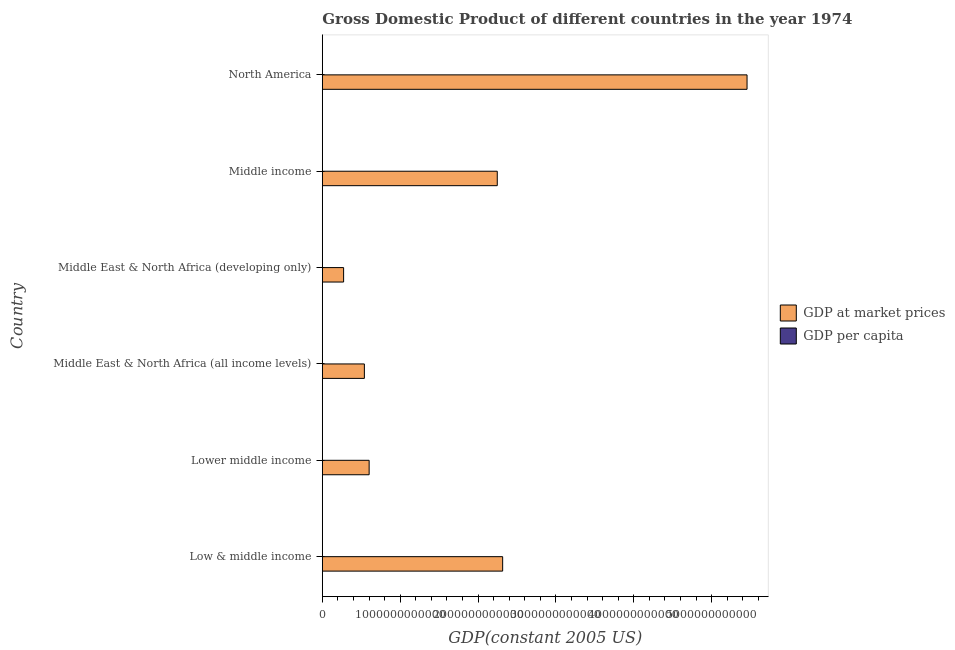How many different coloured bars are there?
Give a very brief answer. 2. Are the number of bars per tick equal to the number of legend labels?
Keep it short and to the point. Yes. Are the number of bars on each tick of the Y-axis equal?
Your response must be concise. Yes. How many bars are there on the 3rd tick from the top?
Provide a short and direct response. 2. In how many cases, is the number of bars for a given country not equal to the number of legend labels?
Make the answer very short. 0. What is the gdp at market prices in Middle East & North Africa (all income levels)?
Provide a short and direct response. 5.40e+11. Across all countries, what is the maximum gdp per capita?
Offer a terse response. 2.30e+04. Across all countries, what is the minimum gdp at market prices?
Offer a very short reply. 2.73e+11. In which country was the gdp at market prices minimum?
Your answer should be very brief. Middle East & North Africa (developing only). What is the total gdp per capita in the graph?
Provide a succinct answer. 3.06e+04. What is the difference between the gdp per capita in Middle income and that in North America?
Keep it short and to the point. -2.22e+04. What is the difference between the gdp per capita in Middle East & North Africa (all income levels) and the gdp at market prices in Middle East & North Africa (developing only)?
Your answer should be compact. -2.73e+11. What is the average gdp at market prices per country?
Ensure brevity in your answer.  1.91e+12. What is the difference between the gdp per capita and gdp at market prices in Low & middle income?
Provide a short and direct response. -2.32e+12. What is the ratio of the gdp per capita in Middle income to that in North America?
Provide a short and direct response. 0.04. What is the difference between the highest and the second highest gdp at market prices?
Your response must be concise. 3.14e+12. What is the difference between the highest and the lowest gdp per capita?
Ensure brevity in your answer.  2.26e+04. In how many countries, is the gdp per capita greater than the average gdp per capita taken over all countries?
Your response must be concise. 1. What does the 1st bar from the top in Low & middle income represents?
Provide a short and direct response. GDP per capita. What does the 2nd bar from the bottom in Low & middle income represents?
Ensure brevity in your answer.  GDP per capita. How many countries are there in the graph?
Give a very brief answer. 6. What is the difference between two consecutive major ticks on the X-axis?
Your answer should be compact. 1.00e+12. Are the values on the major ticks of X-axis written in scientific E-notation?
Your response must be concise. No. Does the graph contain grids?
Keep it short and to the point. No. How many legend labels are there?
Make the answer very short. 2. How are the legend labels stacked?
Your answer should be compact. Vertical. What is the title of the graph?
Your response must be concise. Gross Domestic Product of different countries in the year 1974. What is the label or title of the X-axis?
Your answer should be compact. GDP(constant 2005 US). What is the GDP(constant 2005 US) in GDP at market prices in Low & middle income?
Provide a succinct answer. 2.32e+12. What is the GDP(constant 2005 US) of GDP per capita in Low & middle income?
Make the answer very short. 789.55. What is the GDP(constant 2005 US) of GDP at market prices in Lower middle income?
Provide a short and direct response. 6.01e+11. What is the GDP(constant 2005 US) of GDP per capita in Lower middle income?
Your answer should be very brief. 461.53. What is the GDP(constant 2005 US) in GDP at market prices in Middle East & North Africa (all income levels)?
Offer a terse response. 5.40e+11. What is the GDP(constant 2005 US) in GDP per capita in Middle East & North Africa (all income levels)?
Offer a terse response. 3495.84. What is the GDP(constant 2005 US) of GDP at market prices in Middle East & North Africa (developing only)?
Offer a very short reply. 2.73e+11. What is the GDP(constant 2005 US) in GDP per capita in Middle East & North Africa (developing only)?
Your response must be concise. 1937.94. What is the GDP(constant 2005 US) of GDP at market prices in Middle income?
Give a very brief answer. 2.25e+12. What is the GDP(constant 2005 US) in GDP per capita in Middle income?
Your response must be concise. 827.87. What is the GDP(constant 2005 US) of GDP at market prices in North America?
Your response must be concise. 5.45e+12. What is the GDP(constant 2005 US) of GDP per capita in North America?
Keep it short and to the point. 2.30e+04. Across all countries, what is the maximum GDP(constant 2005 US) in GDP at market prices?
Offer a terse response. 5.45e+12. Across all countries, what is the maximum GDP(constant 2005 US) of GDP per capita?
Give a very brief answer. 2.30e+04. Across all countries, what is the minimum GDP(constant 2005 US) in GDP at market prices?
Give a very brief answer. 2.73e+11. Across all countries, what is the minimum GDP(constant 2005 US) of GDP per capita?
Keep it short and to the point. 461.53. What is the total GDP(constant 2005 US) of GDP at market prices in the graph?
Your answer should be very brief. 1.14e+13. What is the total GDP(constant 2005 US) in GDP per capita in the graph?
Give a very brief answer. 3.06e+04. What is the difference between the GDP(constant 2005 US) in GDP at market prices in Low & middle income and that in Lower middle income?
Keep it short and to the point. 1.71e+12. What is the difference between the GDP(constant 2005 US) of GDP per capita in Low & middle income and that in Lower middle income?
Your answer should be compact. 328.03. What is the difference between the GDP(constant 2005 US) in GDP at market prices in Low & middle income and that in Middle East & North Africa (all income levels)?
Make the answer very short. 1.78e+12. What is the difference between the GDP(constant 2005 US) of GDP per capita in Low & middle income and that in Middle East & North Africa (all income levels)?
Provide a succinct answer. -2706.29. What is the difference between the GDP(constant 2005 US) in GDP at market prices in Low & middle income and that in Middle East & North Africa (developing only)?
Provide a short and direct response. 2.04e+12. What is the difference between the GDP(constant 2005 US) in GDP per capita in Low & middle income and that in Middle East & North Africa (developing only)?
Provide a short and direct response. -1148.39. What is the difference between the GDP(constant 2005 US) of GDP at market prices in Low & middle income and that in Middle income?
Offer a very short reply. 6.92e+1. What is the difference between the GDP(constant 2005 US) in GDP per capita in Low & middle income and that in Middle income?
Ensure brevity in your answer.  -38.32. What is the difference between the GDP(constant 2005 US) of GDP at market prices in Low & middle income and that in North America?
Give a very brief answer. -3.14e+12. What is the difference between the GDP(constant 2005 US) of GDP per capita in Low & middle income and that in North America?
Make the answer very short. -2.23e+04. What is the difference between the GDP(constant 2005 US) of GDP at market prices in Lower middle income and that in Middle East & North Africa (all income levels)?
Offer a terse response. 6.12e+1. What is the difference between the GDP(constant 2005 US) in GDP per capita in Lower middle income and that in Middle East & North Africa (all income levels)?
Offer a very short reply. -3034.31. What is the difference between the GDP(constant 2005 US) in GDP at market prices in Lower middle income and that in Middle East & North Africa (developing only)?
Provide a succinct answer. 3.28e+11. What is the difference between the GDP(constant 2005 US) of GDP per capita in Lower middle income and that in Middle East & North Africa (developing only)?
Provide a succinct answer. -1476.42. What is the difference between the GDP(constant 2005 US) in GDP at market prices in Lower middle income and that in Middle income?
Offer a very short reply. -1.65e+12. What is the difference between the GDP(constant 2005 US) of GDP per capita in Lower middle income and that in Middle income?
Provide a succinct answer. -366.34. What is the difference between the GDP(constant 2005 US) in GDP at market prices in Lower middle income and that in North America?
Provide a short and direct response. -4.85e+12. What is the difference between the GDP(constant 2005 US) in GDP per capita in Lower middle income and that in North America?
Provide a short and direct response. -2.26e+04. What is the difference between the GDP(constant 2005 US) in GDP at market prices in Middle East & North Africa (all income levels) and that in Middle East & North Africa (developing only)?
Ensure brevity in your answer.  2.67e+11. What is the difference between the GDP(constant 2005 US) in GDP per capita in Middle East & North Africa (all income levels) and that in Middle East & North Africa (developing only)?
Your response must be concise. 1557.9. What is the difference between the GDP(constant 2005 US) in GDP at market prices in Middle East & North Africa (all income levels) and that in Middle income?
Provide a succinct answer. -1.71e+12. What is the difference between the GDP(constant 2005 US) of GDP per capita in Middle East & North Africa (all income levels) and that in Middle income?
Provide a succinct answer. 2667.97. What is the difference between the GDP(constant 2005 US) of GDP at market prices in Middle East & North Africa (all income levels) and that in North America?
Offer a very short reply. -4.91e+12. What is the difference between the GDP(constant 2005 US) in GDP per capita in Middle East & North Africa (all income levels) and that in North America?
Your response must be concise. -1.95e+04. What is the difference between the GDP(constant 2005 US) in GDP at market prices in Middle East & North Africa (developing only) and that in Middle income?
Provide a succinct answer. -1.97e+12. What is the difference between the GDP(constant 2005 US) of GDP per capita in Middle East & North Africa (developing only) and that in Middle income?
Your answer should be compact. 1110.07. What is the difference between the GDP(constant 2005 US) in GDP at market prices in Middle East & North Africa (developing only) and that in North America?
Offer a terse response. -5.18e+12. What is the difference between the GDP(constant 2005 US) of GDP per capita in Middle East & North Africa (developing only) and that in North America?
Make the answer very short. -2.11e+04. What is the difference between the GDP(constant 2005 US) in GDP at market prices in Middle income and that in North America?
Your answer should be very brief. -3.21e+12. What is the difference between the GDP(constant 2005 US) of GDP per capita in Middle income and that in North America?
Make the answer very short. -2.22e+04. What is the difference between the GDP(constant 2005 US) in GDP at market prices in Low & middle income and the GDP(constant 2005 US) in GDP per capita in Lower middle income?
Your answer should be compact. 2.32e+12. What is the difference between the GDP(constant 2005 US) of GDP at market prices in Low & middle income and the GDP(constant 2005 US) of GDP per capita in Middle East & North Africa (all income levels)?
Your answer should be compact. 2.32e+12. What is the difference between the GDP(constant 2005 US) in GDP at market prices in Low & middle income and the GDP(constant 2005 US) in GDP per capita in Middle East & North Africa (developing only)?
Give a very brief answer. 2.32e+12. What is the difference between the GDP(constant 2005 US) of GDP at market prices in Low & middle income and the GDP(constant 2005 US) of GDP per capita in Middle income?
Ensure brevity in your answer.  2.32e+12. What is the difference between the GDP(constant 2005 US) of GDP at market prices in Low & middle income and the GDP(constant 2005 US) of GDP per capita in North America?
Offer a terse response. 2.32e+12. What is the difference between the GDP(constant 2005 US) in GDP at market prices in Lower middle income and the GDP(constant 2005 US) in GDP per capita in Middle East & North Africa (all income levels)?
Ensure brevity in your answer.  6.01e+11. What is the difference between the GDP(constant 2005 US) of GDP at market prices in Lower middle income and the GDP(constant 2005 US) of GDP per capita in Middle East & North Africa (developing only)?
Offer a very short reply. 6.01e+11. What is the difference between the GDP(constant 2005 US) in GDP at market prices in Lower middle income and the GDP(constant 2005 US) in GDP per capita in Middle income?
Your answer should be very brief. 6.01e+11. What is the difference between the GDP(constant 2005 US) in GDP at market prices in Lower middle income and the GDP(constant 2005 US) in GDP per capita in North America?
Provide a short and direct response. 6.01e+11. What is the difference between the GDP(constant 2005 US) in GDP at market prices in Middle East & North Africa (all income levels) and the GDP(constant 2005 US) in GDP per capita in Middle East & North Africa (developing only)?
Offer a very short reply. 5.40e+11. What is the difference between the GDP(constant 2005 US) in GDP at market prices in Middle East & North Africa (all income levels) and the GDP(constant 2005 US) in GDP per capita in Middle income?
Ensure brevity in your answer.  5.40e+11. What is the difference between the GDP(constant 2005 US) in GDP at market prices in Middle East & North Africa (all income levels) and the GDP(constant 2005 US) in GDP per capita in North America?
Offer a very short reply. 5.40e+11. What is the difference between the GDP(constant 2005 US) in GDP at market prices in Middle East & North Africa (developing only) and the GDP(constant 2005 US) in GDP per capita in Middle income?
Keep it short and to the point. 2.73e+11. What is the difference between the GDP(constant 2005 US) of GDP at market prices in Middle East & North Africa (developing only) and the GDP(constant 2005 US) of GDP per capita in North America?
Make the answer very short. 2.73e+11. What is the difference between the GDP(constant 2005 US) of GDP at market prices in Middle income and the GDP(constant 2005 US) of GDP per capita in North America?
Your answer should be compact. 2.25e+12. What is the average GDP(constant 2005 US) in GDP at market prices per country?
Give a very brief answer. 1.91e+12. What is the average GDP(constant 2005 US) of GDP per capita per country?
Give a very brief answer. 5092.69. What is the difference between the GDP(constant 2005 US) of GDP at market prices and GDP(constant 2005 US) of GDP per capita in Low & middle income?
Your answer should be very brief. 2.32e+12. What is the difference between the GDP(constant 2005 US) of GDP at market prices and GDP(constant 2005 US) of GDP per capita in Lower middle income?
Keep it short and to the point. 6.01e+11. What is the difference between the GDP(constant 2005 US) in GDP at market prices and GDP(constant 2005 US) in GDP per capita in Middle East & North Africa (all income levels)?
Offer a very short reply. 5.40e+11. What is the difference between the GDP(constant 2005 US) in GDP at market prices and GDP(constant 2005 US) in GDP per capita in Middle East & North Africa (developing only)?
Your answer should be compact. 2.73e+11. What is the difference between the GDP(constant 2005 US) of GDP at market prices and GDP(constant 2005 US) of GDP per capita in Middle income?
Keep it short and to the point. 2.25e+12. What is the difference between the GDP(constant 2005 US) of GDP at market prices and GDP(constant 2005 US) of GDP per capita in North America?
Your answer should be compact. 5.45e+12. What is the ratio of the GDP(constant 2005 US) of GDP at market prices in Low & middle income to that in Lower middle income?
Ensure brevity in your answer.  3.85. What is the ratio of the GDP(constant 2005 US) of GDP per capita in Low & middle income to that in Lower middle income?
Your answer should be compact. 1.71. What is the ratio of the GDP(constant 2005 US) of GDP at market prices in Low & middle income to that in Middle East & North Africa (all income levels)?
Your answer should be very brief. 4.29. What is the ratio of the GDP(constant 2005 US) in GDP per capita in Low & middle income to that in Middle East & North Africa (all income levels)?
Make the answer very short. 0.23. What is the ratio of the GDP(constant 2005 US) of GDP at market prices in Low & middle income to that in Middle East & North Africa (developing only)?
Provide a short and direct response. 8.47. What is the ratio of the GDP(constant 2005 US) of GDP per capita in Low & middle income to that in Middle East & North Africa (developing only)?
Your answer should be compact. 0.41. What is the ratio of the GDP(constant 2005 US) of GDP at market prices in Low & middle income to that in Middle income?
Give a very brief answer. 1.03. What is the ratio of the GDP(constant 2005 US) of GDP per capita in Low & middle income to that in Middle income?
Provide a succinct answer. 0.95. What is the ratio of the GDP(constant 2005 US) of GDP at market prices in Low & middle income to that in North America?
Keep it short and to the point. 0.42. What is the ratio of the GDP(constant 2005 US) in GDP per capita in Low & middle income to that in North America?
Your answer should be very brief. 0.03. What is the ratio of the GDP(constant 2005 US) of GDP at market prices in Lower middle income to that in Middle East & North Africa (all income levels)?
Your answer should be compact. 1.11. What is the ratio of the GDP(constant 2005 US) in GDP per capita in Lower middle income to that in Middle East & North Africa (all income levels)?
Your response must be concise. 0.13. What is the ratio of the GDP(constant 2005 US) of GDP at market prices in Lower middle income to that in Middle East & North Africa (developing only)?
Offer a very short reply. 2.2. What is the ratio of the GDP(constant 2005 US) in GDP per capita in Lower middle income to that in Middle East & North Africa (developing only)?
Your answer should be very brief. 0.24. What is the ratio of the GDP(constant 2005 US) of GDP at market prices in Lower middle income to that in Middle income?
Make the answer very short. 0.27. What is the ratio of the GDP(constant 2005 US) of GDP per capita in Lower middle income to that in Middle income?
Provide a short and direct response. 0.56. What is the ratio of the GDP(constant 2005 US) in GDP at market prices in Lower middle income to that in North America?
Give a very brief answer. 0.11. What is the ratio of the GDP(constant 2005 US) of GDP per capita in Lower middle income to that in North America?
Offer a very short reply. 0.02. What is the ratio of the GDP(constant 2005 US) in GDP at market prices in Middle East & North Africa (all income levels) to that in Middle East & North Africa (developing only)?
Offer a very short reply. 1.98. What is the ratio of the GDP(constant 2005 US) in GDP per capita in Middle East & North Africa (all income levels) to that in Middle East & North Africa (developing only)?
Offer a terse response. 1.8. What is the ratio of the GDP(constant 2005 US) of GDP at market prices in Middle East & North Africa (all income levels) to that in Middle income?
Offer a terse response. 0.24. What is the ratio of the GDP(constant 2005 US) of GDP per capita in Middle East & North Africa (all income levels) to that in Middle income?
Your answer should be compact. 4.22. What is the ratio of the GDP(constant 2005 US) of GDP at market prices in Middle East & North Africa (all income levels) to that in North America?
Ensure brevity in your answer.  0.1. What is the ratio of the GDP(constant 2005 US) of GDP per capita in Middle East & North Africa (all income levels) to that in North America?
Keep it short and to the point. 0.15. What is the ratio of the GDP(constant 2005 US) of GDP at market prices in Middle East & North Africa (developing only) to that in Middle income?
Keep it short and to the point. 0.12. What is the ratio of the GDP(constant 2005 US) in GDP per capita in Middle East & North Africa (developing only) to that in Middle income?
Provide a succinct answer. 2.34. What is the ratio of the GDP(constant 2005 US) in GDP at market prices in Middle East & North Africa (developing only) to that in North America?
Your answer should be very brief. 0.05. What is the ratio of the GDP(constant 2005 US) in GDP per capita in Middle East & North Africa (developing only) to that in North America?
Offer a very short reply. 0.08. What is the ratio of the GDP(constant 2005 US) in GDP at market prices in Middle income to that in North America?
Your response must be concise. 0.41. What is the ratio of the GDP(constant 2005 US) in GDP per capita in Middle income to that in North America?
Your response must be concise. 0.04. What is the difference between the highest and the second highest GDP(constant 2005 US) in GDP at market prices?
Ensure brevity in your answer.  3.14e+12. What is the difference between the highest and the second highest GDP(constant 2005 US) of GDP per capita?
Your answer should be very brief. 1.95e+04. What is the difference between the highest and the lowest GDP(constant 2005 US) of GDP at market prices?
Provide a succinct answer. 5.18e+12. What is the difference between the highest and the lowest GDP(constant 2005 US) of GDP per capita?
Keep it short and to the point. 2.26e+04. 